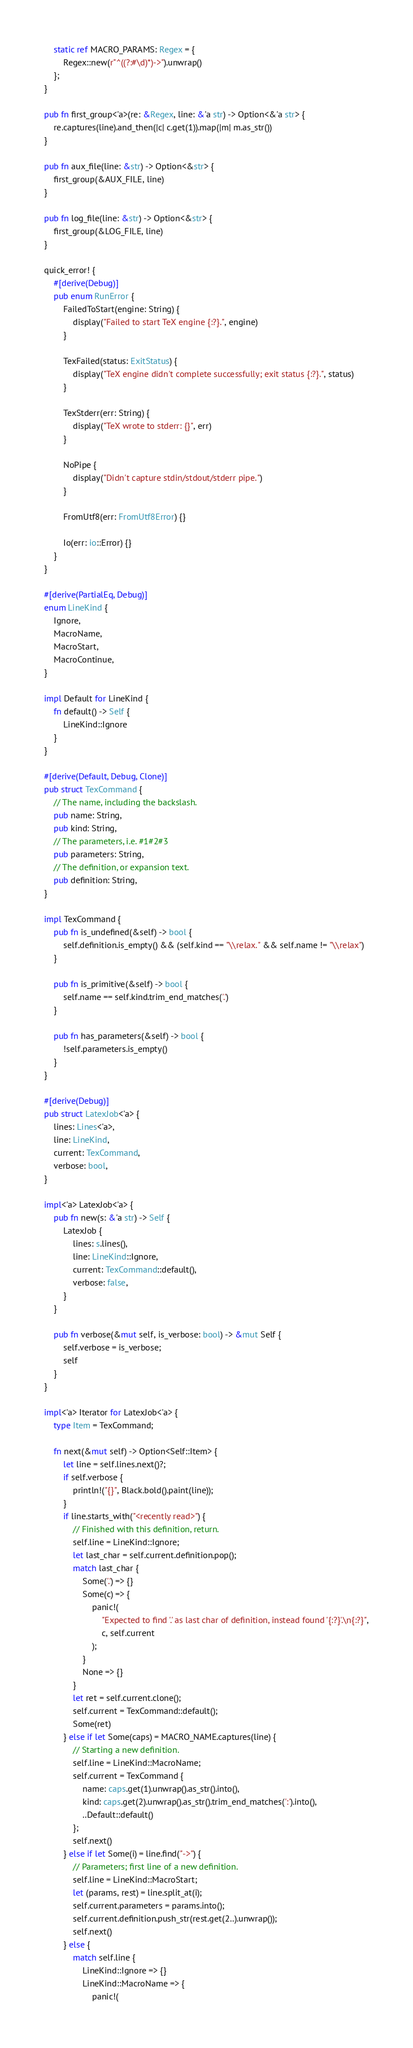Convert code to text. <code><loc_0><loc_0><loc_500><loc_500><_Rust_>    static ref MACRO_PARAMS: Regex = {
        Regex::new(r"^((?:#\d)*)->").unwrap()
    };
}

pub fn first_group<'a>(re: &Regex, line: &'a str) -> Option<&'a str> {
    re.captures(line).and_then(|c| c.get(1)).map(|m| m.as_str())
}

pub fn aux_file(line: &str) -> Option<&str> {
    first_group(&AUX_FILE, line)
}

pub fn log_file(line: &str) -> Option<&str> {
    first_group(&LOG_FILE, line)
}

quick_error! {
    #[derive(Debug)]
    pub enum RunError {
        FailedToStart(engine: String) {
            display("Failed to start TeX engine {:?}.", engine)
        }

        TexFailed(status: ExitStatus) {
            display("TeX engine didn't complete successfully; exit status {:?}.", status)
        }

        TexStderr(err: String) {
            display("TeX wrote to stderr: {}", err)
        }

        NoPipe {
            display("Didn't capture stdin/stdout/stderr pipe.")
        }

        FromUtf8(err: FromUtf8Error) {}

        Io(err: io::Error) {}
    }
}

#[derive(PartialEq, Debug)]
enum LineKind {
    Ignore,
    MacroName,
    MacroStart,
    MacroContinue,
}

impl Default for LineKind {
    fn default() -> Self {
        LineKind::Ignore
    }
}

#[derive(Default, Debug, Clone)]
pub struct TexCommand {
    // The name, including the backslash.
    pub name: String,
    pub kind: String,
    // The parameters, i.e. #1#2#3
    pub parameters: String,
    // The definition, or expansion text.
    pub definition: String,
}

impl TexCommand {
    pub fn is_undefined(&self) -> bool {
        self.definition.is_empty() && (self.kind == "\\relax." && self.name != "\\relax")
    }

    pub fn is_primitive(&self) -> bool {
        self.name == self.kind.trim_end_matches('.')
    }

    pub fn has_parameters(&self) -> bool {
        !self.parameters.is_empty()
    }
}

#[derive(Debug)]
pub struct LatexJob<'a> {
    lines: Lines<'a>,
    line: LineKind,
    current: TexCommand,
    verbose: bool,
}

impl<'a> LatexJob<'a> {
    pub fn new(s: &'a str) -> Self {
        LatexJob {
            lines: s.lines(),
            line: LineKind::Ignore,
            current: TexCommand::default(),
            verbose: false,
        }
    }

    pub fn verbose(&mut self, is_verbose: bool) -> &mut Self {
        self.verbose = is_verbose;
        self
    }
}

impl<'a> Iterator for LatexJob<'a> {
    type Item = TexCommand;

    fn next(&mut self) -> Option<Self::Item> {
        let line = self.lines.next()?;
        if self.verbose {
            println!("{}", Black.bold().paint(line));
        }
        if line.starts_with("<recently read>") {
            // Finished with this definition, return.
            self.line = LineKind::Ignore;
            let last_char = self.current.definition.pop();
            match last_char {
                Some('.') => {}
                Some(c) => {
                    panic!(
                        "Expected to find '.' as last char of definition, instead found '{:?}'.\n{:?}",
                        c, self.current
                    );
                }
                None => {}
            }
            let ret = self.current.clone();
            self.current = TexCommand::default();
            Some(ret)
        } else if let Some(caps) = MACRO_NAME.captures(line) {
            // Starting a new definition.
            self.line = LineKind::MacroName;
            self.current = TexCommand {
                name: caps.get(1).unwrap().as_str().into(),
                kind: caps.get(2).unwrap().as_str().trim_end_matches(':').into(),
                ..Default::default()
            };
            self.next()
        } else if let Some(i) = line.find("->") {
            // Parameters; first line of a new definition.
            self.line = LineKind::MacroStart;
            let (params, rest) = line.split_at(i);
            self.current.parameters = params.into();
            self.current.definition.push_str(rest.get(2..).unwrap());
            self.next()
        } else {
            match self.line {
                LineKind::Ignore => {}
                LineKind::MacroName => {
                    panic!(</code> 